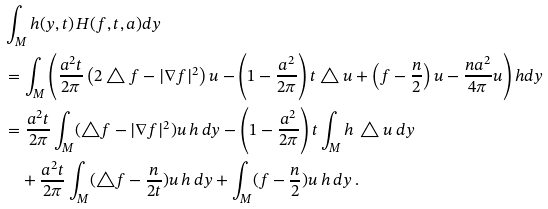<formula> <loc_0><loc_0><loc_500><loc_500>& \int _ { M } h ( y , t ) \, H ( f , t , a ) d y \\ & = \int _ { M } \left ( \frac { a ^ { 2 } t } { 2 \pi } \left ( 2 \triangle f - | \nabla f | ^ { 2 } \right ) u - \left ( 1 - \frac { a ^ { 2 } } { 2 \pi } \right ) t \triangle u + \left ( f - \frac { n } { 2 } \right ) u - \frac { n a ^ { 2 } } { 4 \pi } u \right ) h d y \\ & = \frac { a ^ { 2 } t } { 2 \pi } \int _ { M } ( \triangle f - | \nabla f | ^ { 2 } ) u \, h \, d y - \left ( 1 - \frac { a ^ { 2 } } { 2 \pi } \right ) t \int _ { M } h \, \triangle u \, d y \\ & \quad + \frac { a ^ { 2 } t } { 2 \pi } \int _ { M } ( \triangle f - \frac { n } { 2 t } ) u \, h \, d y + \int _ { M } ( f - \frac { n } { 2 } ) u \, h \, d y \, .</formula> 